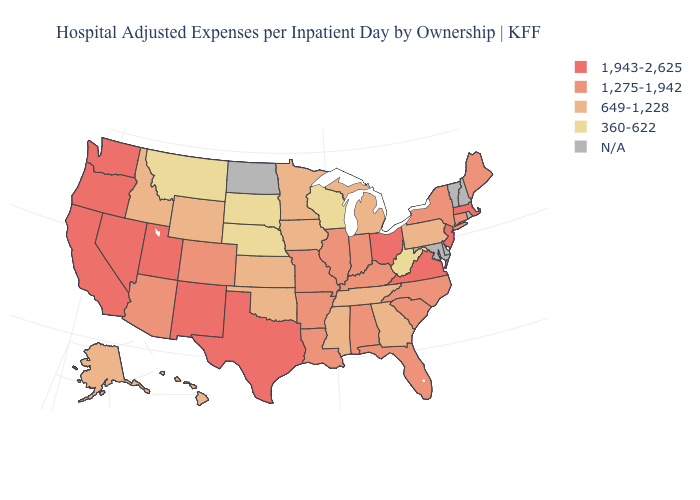Which states hav the highest value in the MidWest?
Be succinct. Ohio. How many symbols are there in the legend?
Give a very brief answer. 5. Among the states that border Illinois , does Wisconsin have the lowest value?
Write a very short answer. Yes. What is the highest value in the USA?
Concise answer only. 1,943-2,625. What is the highest value in the Northeast ?
Give a very brief answer. 1,943-2,625. What is the value of Idaho?
Concise answer only. 649-1,228. What is the value of Iowa?
Quick response, please. 649-1,228. What is the highest value in states that border Georgia?
Give a very brief answer. 1,275-1,942. What is the highest value in the MidWest ?
Give a very brief answer. 1,943-2,625. What is the value of Oklahoma?
Concise answer only. 649-1,228. Does the first symbol in the legend represent the smallest category?
Quick response, please. No. Among the states that border Kansas , does Colorado have the lowest value?
Short answer required. No. Name the states that have a value in the range 1,943-2,625?
Give a very brief answer. California, Massachusetts, Nevada, New Jersey, New Mexico, Ohio, Oregon, Texas, Utah, Virginia, Washington. Among the states that border Florida , does Alabama have the lowest value?
Concise answer only. No. 